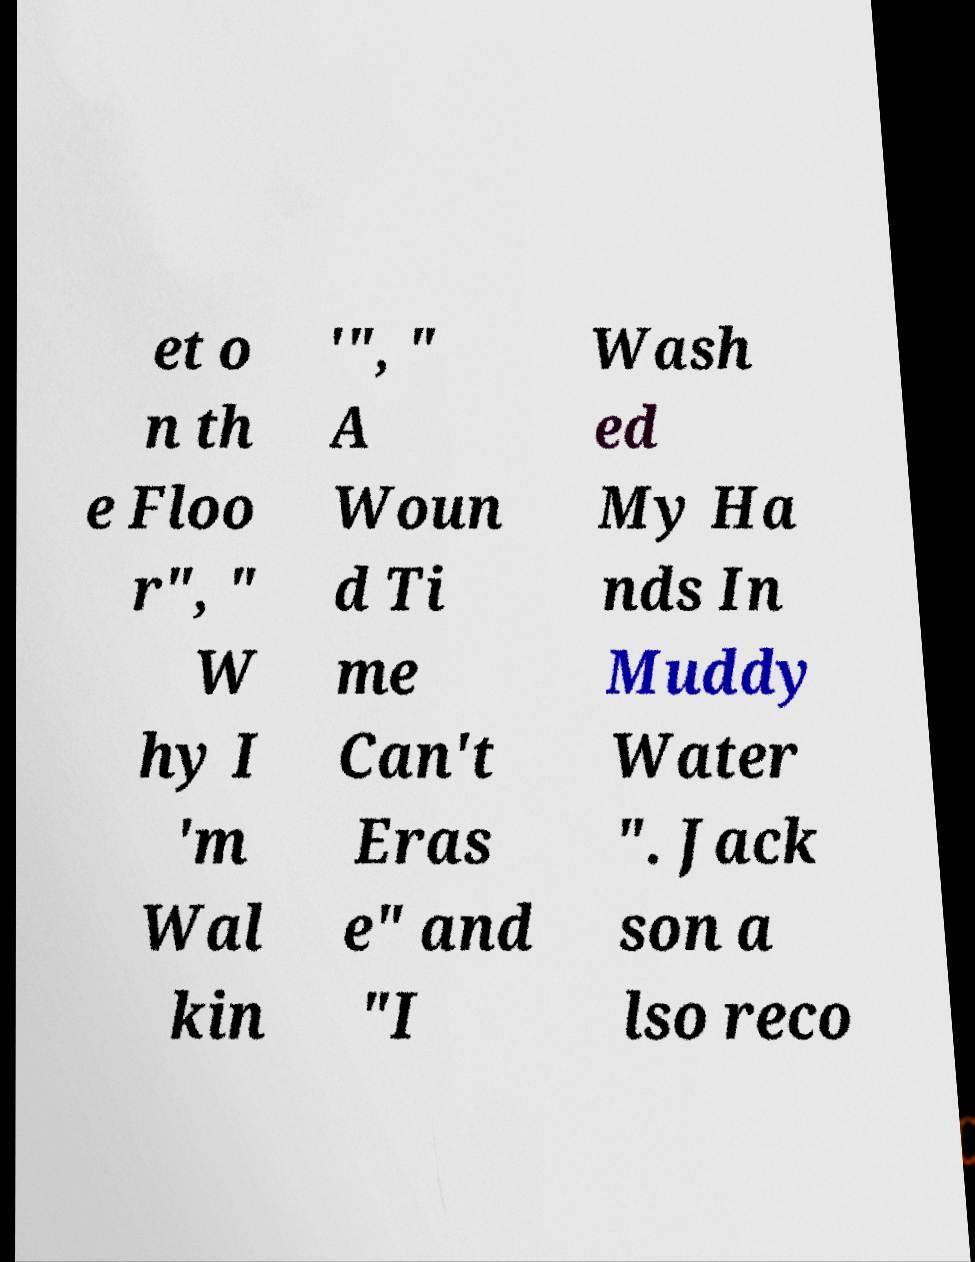What messages or text are displayed in this image? I need them in a readable, typed format. et o n th e Floo r", " W hy I 'm Wal kin '", " A Woun d Ti me Can't Eras e" and "I Wash ed My Ha nds In Muddy Water ". Jack son a lso reco 